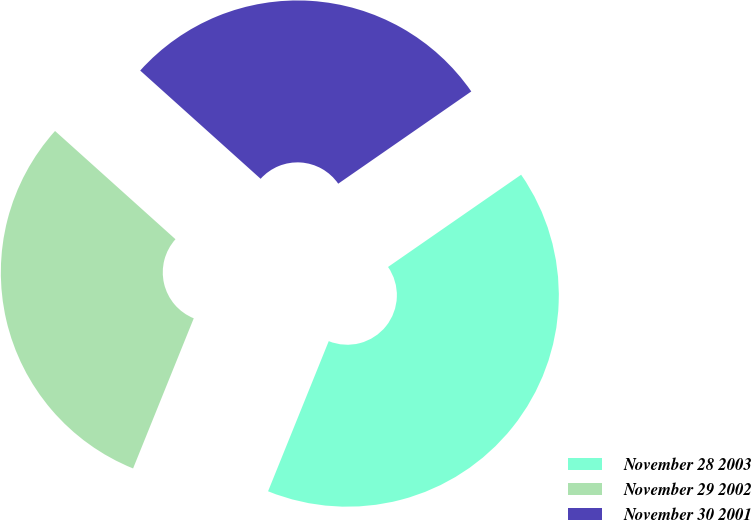<chart> <loc_0><loc_0><loc_500><loc_500><pie_chart><fcel>November 28 2003<fcel>November 29 2002<fcel>November 30 2001<nl><fcel>40.76%<fcel>30.54%<fcel>28.7%<nl></chart> 